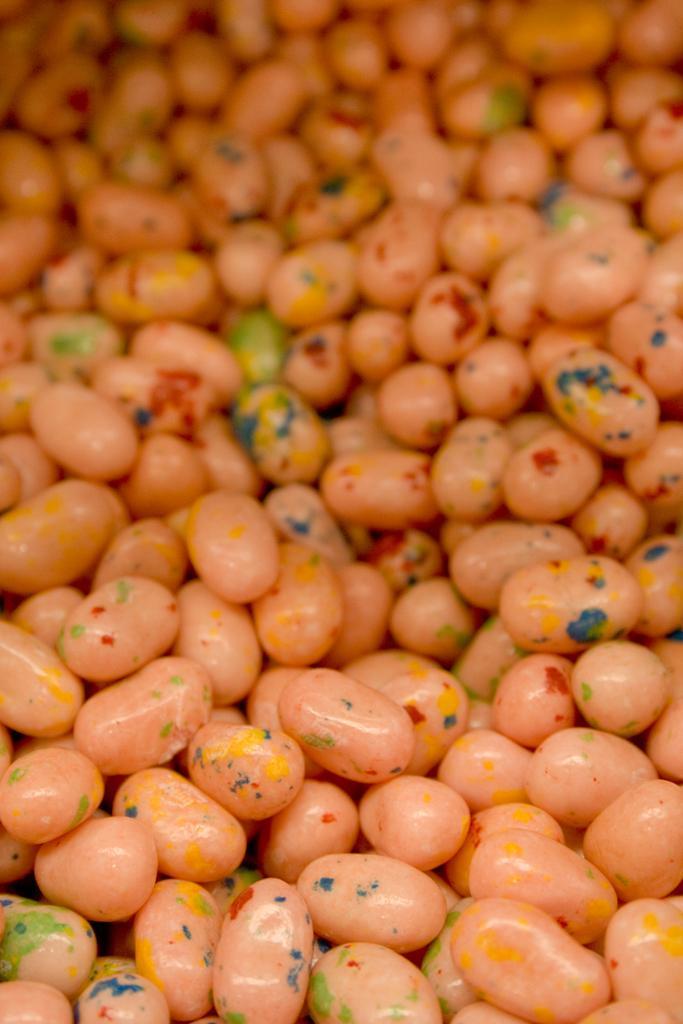Please provide a concise description of this image. In this picture those are looking like the peas. 